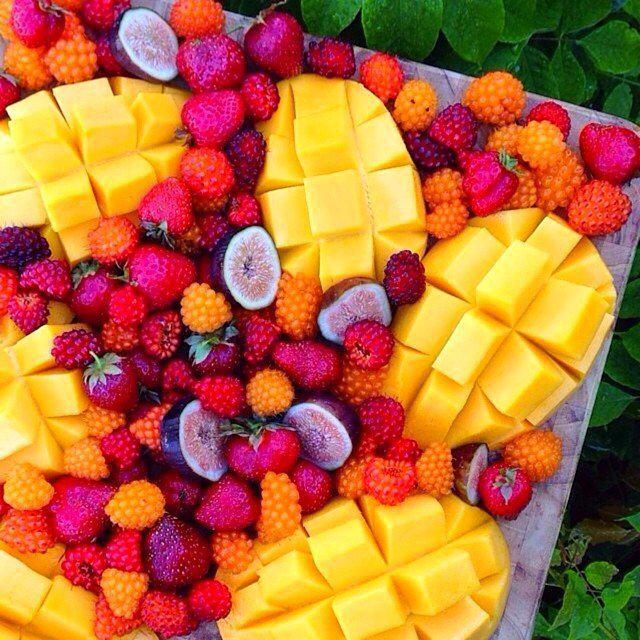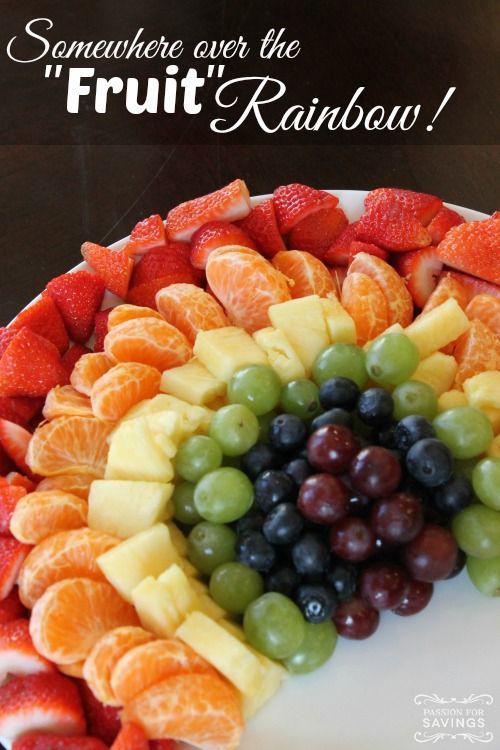The first image is the image on the left, the second image is the image on the right. Assess this claim about the two images: "Right image shows fruit forming half-circle rainbow shape without use of spears.". Correct or not? Answer yes or no. Yes. 